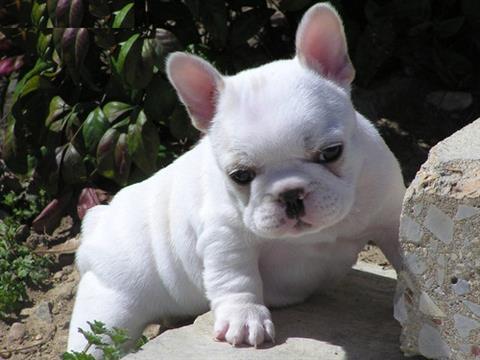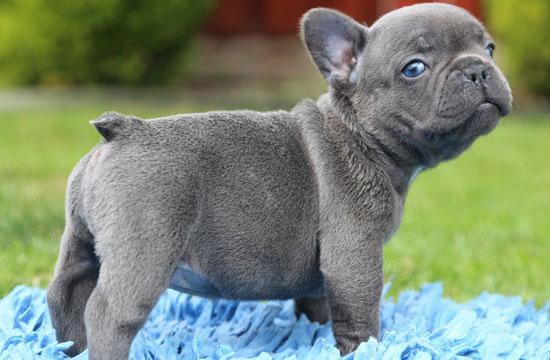The first image is the image on the left, the second image is the image on the right. For the images displayed, is the sentence "There are seven dogs." factually correct? Answer yes or no. No. The first image is the image on the left, the second image is the image on the right. For the images shown, is this caption "there are three french bulldogs, the dog in the middle has a white chest" true? Answer yes or no. No. 